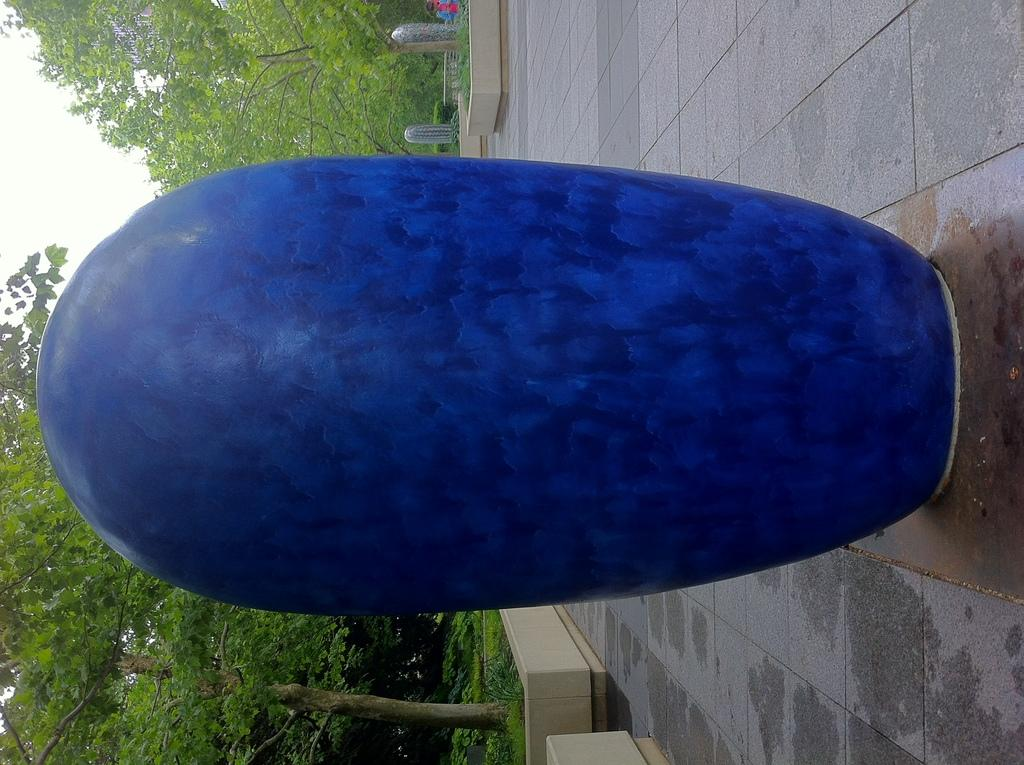What is the color of the object on the ground in the image? The object on the ground in the image is blue. What can be seen in the distance behind the blue object? Trees, plants, other objects, and the sky are visible in the background of the image. Where are the houses located in the image? There are no houses present in the image. What type of popcorn is being served in the image? There is no popcorn present in the image. 